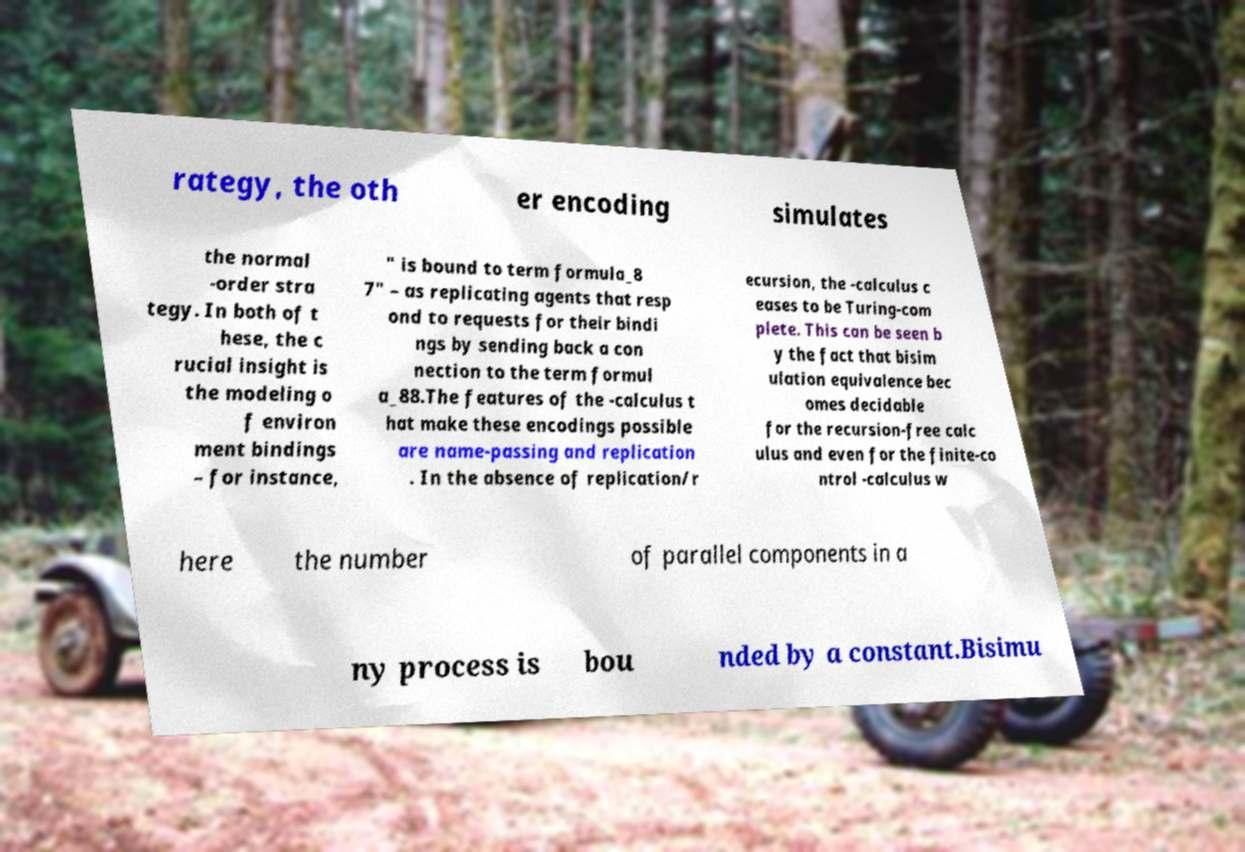Please read and relay the text visible in this image. What does it say? rategy, the oth er encoding simulates the normal -order stra tegy. In both of t hese, the c rucial insight is the modeling o f environ ment bindings – for instance, " is bound to term formula_8 7" – as replicating agents that resp ond to requests for their bindi ngs by sending back a con nection to the term formul a_88.The features of the -calculus t hat make these encodings possible are name-passing and replication . In the absence of replication/r ecursion, the -calculus c eases to be Turing-com plete. This can be seen b y the fact that bisim ulation equivalence bec omes decidable for the recursion-free calc ulus and even for the finite-co ntrol -calculus w here the number of parallel components in a ny process is bou nded by a constant.Bisimu 